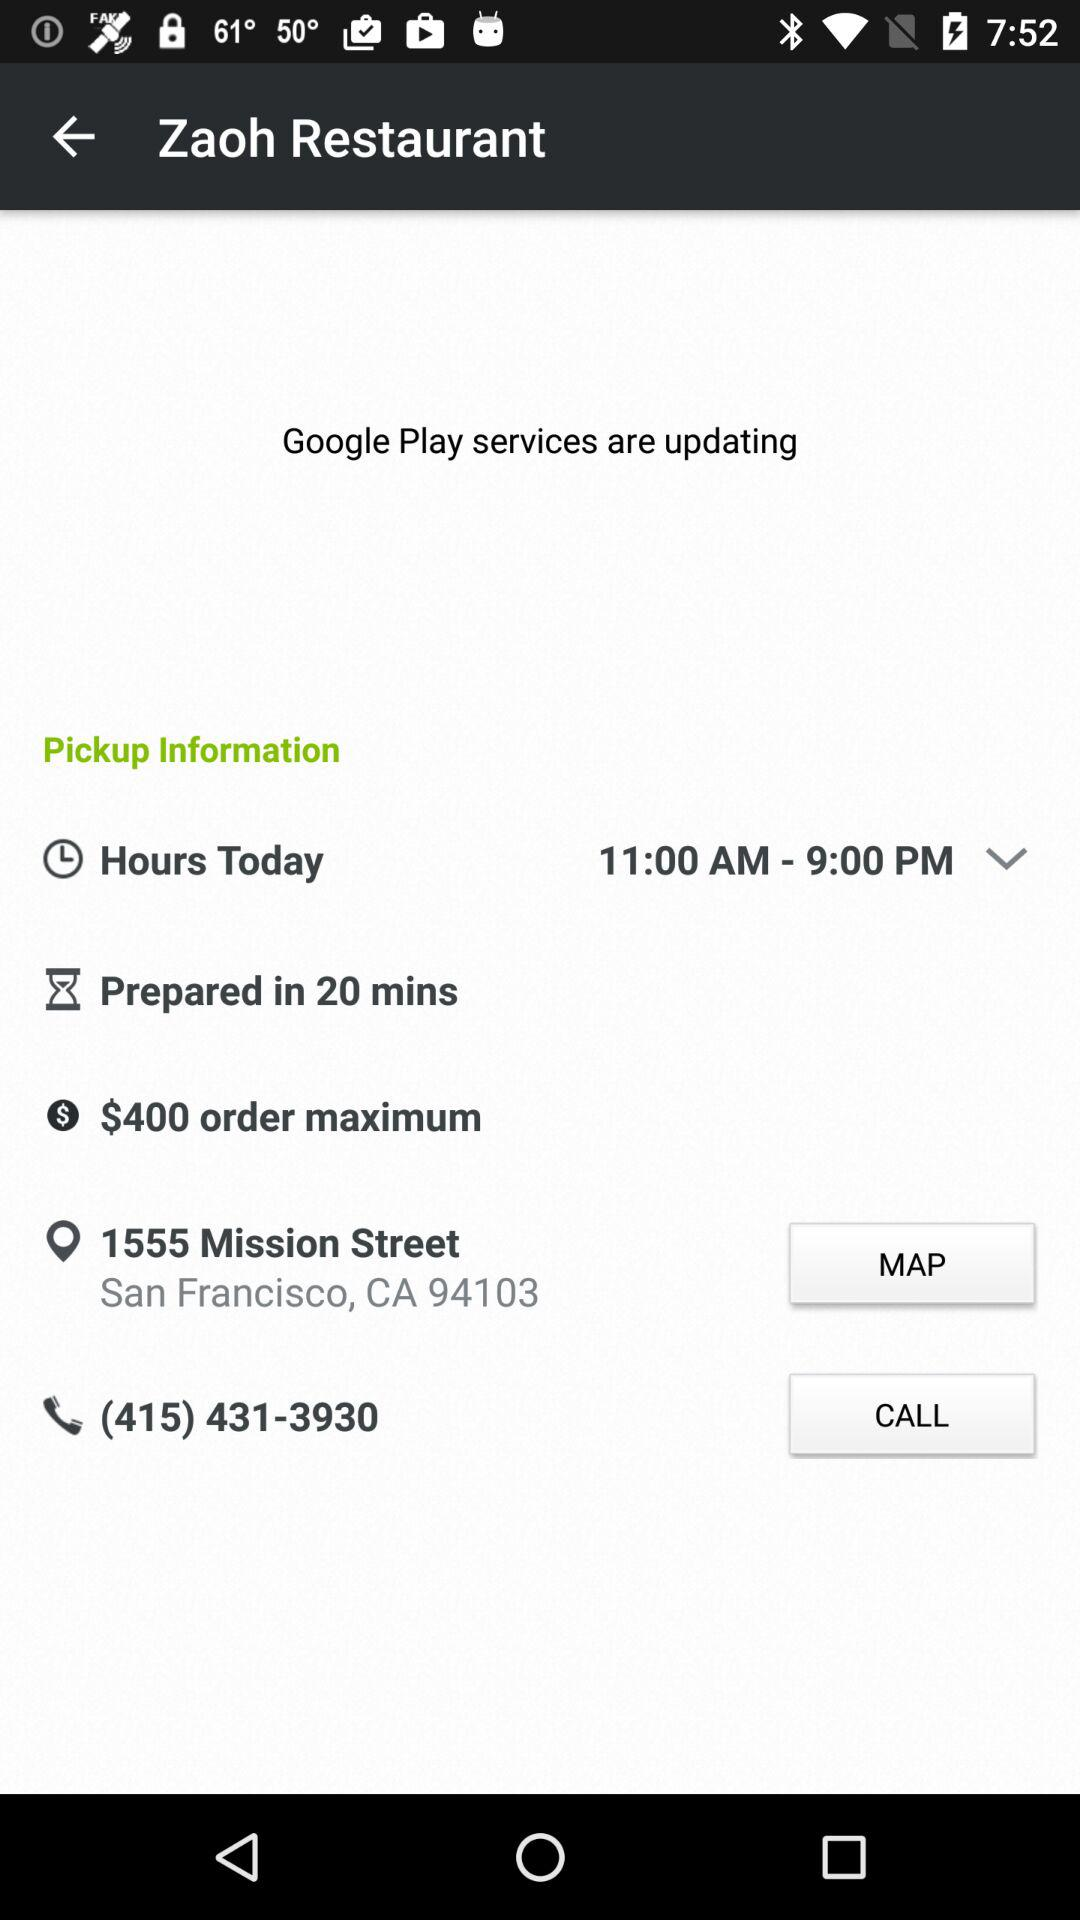What's the preparation time? The preparation time is 20 minutes. 